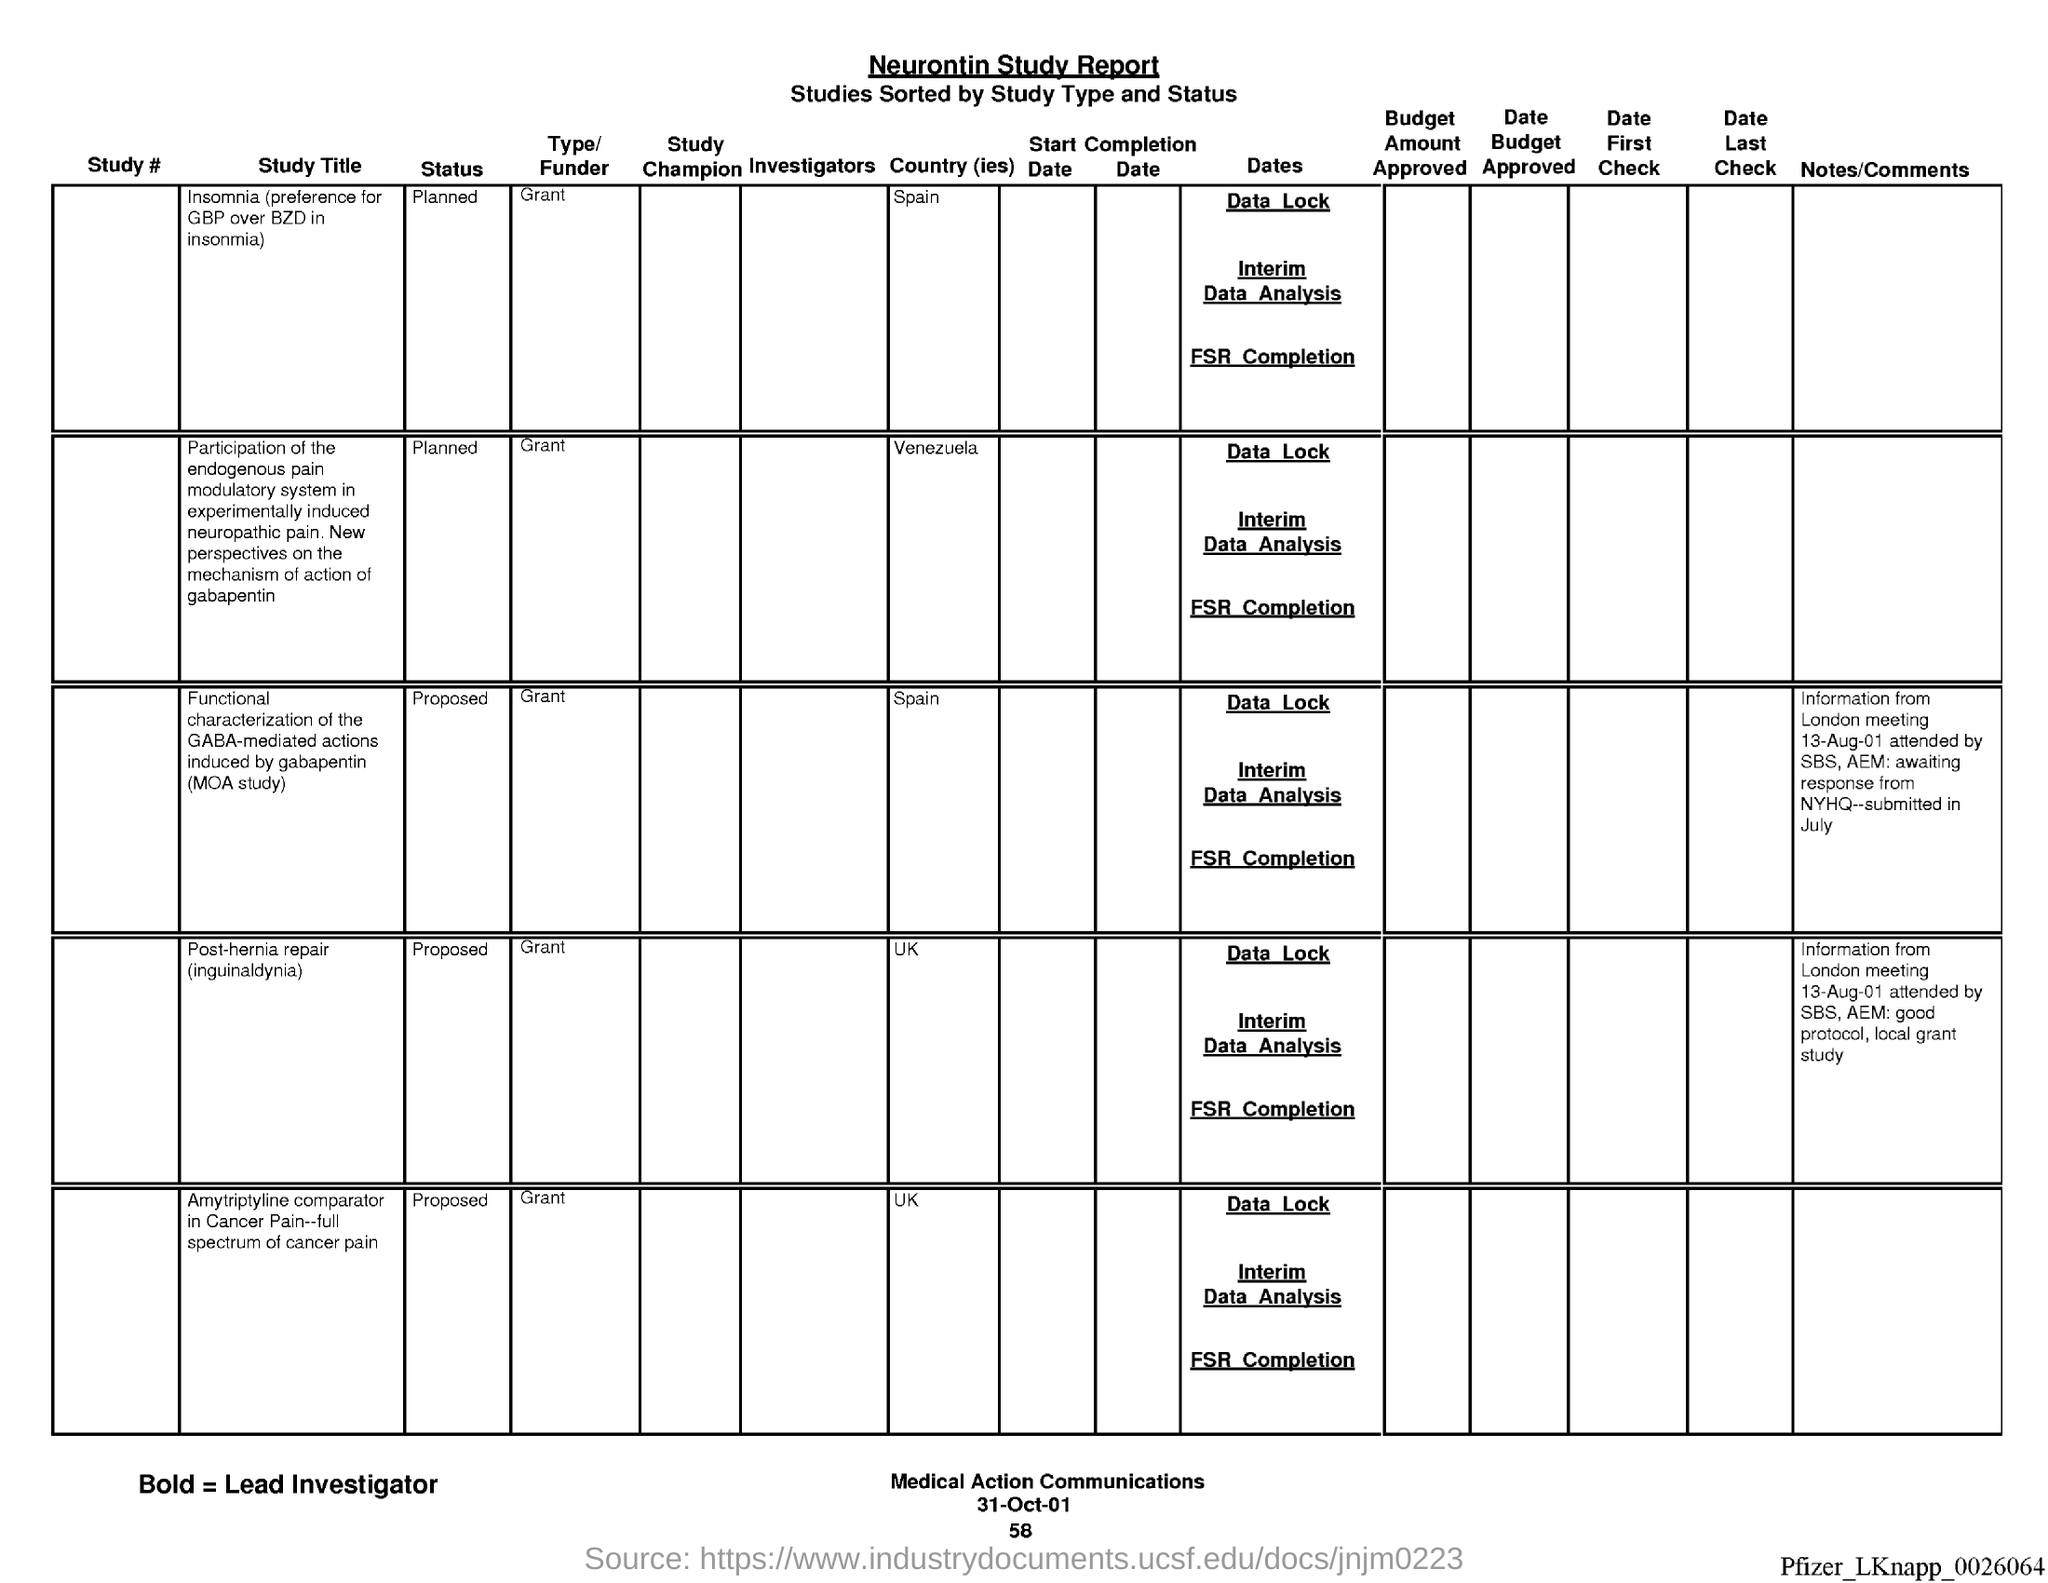What is the document about?
Provide a short and direct response. Neurontin Study Report. What is the date?
Your answer should be very brief. 31-Oct-01. 